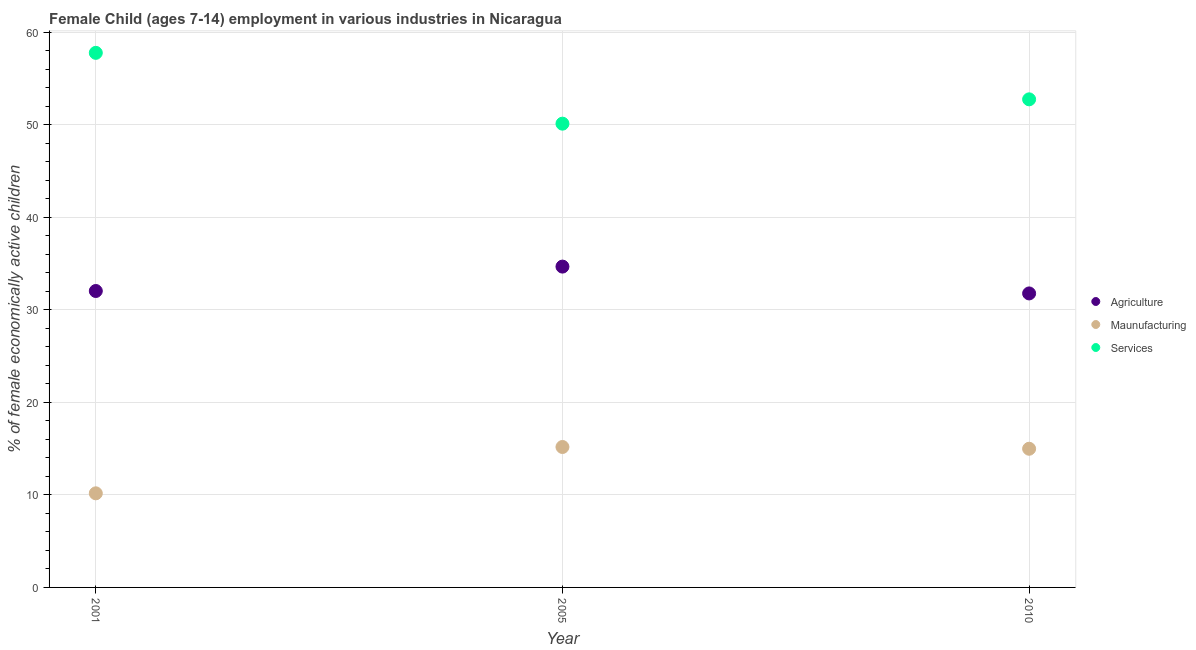How many different coloured dotlines are there?
Make the answer very short. 3. What is the percentage of economically active children in manufacturing in 2005?
Your answer should be compact. 15.18. Across all years, what is the maximum percentage of economically active children in agriculture?
Provide a succinct answer. 34.68. Across all years, what is the minimum percentage of economically active children in agriculture?
Ensure brevity in your answer.  31.78. In which year was the percentage of economically active children in manufacturing maximum?
Your answer should be compact. 2005. In which year was the percentage of economically active children in agriculture minimum?
Provide a short and direct response. 2010. What is the total percentage of economically active children in agriculture in the graph?
Make the answer very short. 98.5. What is the difference between the percentage of economically active children in agriculture in 2005 and that in 2010?
Provide a succinct answer. 2.9. What is the difference between the percentage of economically active children in services in 2001 and the percentage of economically active children in manufacturing in 2005?
Make the answer very short. 42.61. What is the average percentage of economically active children in services per year?
Provide a succinct answer. 53.56. In the year 2010, what is the difference between the percentage of economically active children in agriculture and percentage of economically active children in manufacturing?
Offer a terse response. 16.79. In how many years, is the percentage of economically active children in agriculture greater than 52 %?
Provide a succinct answer. 0. What is the ratio of the percentage of economically active children in agriculture in 2005 to that in 2010?
Your answer should be compact. 1.09. Is the percentage of economically active children in agriculture in 2001 less than that in 2005?
Your answer should be very brief. Yes. Is the difference between the percentage of economically active children in manufacturing in 2001 and 2010 greater than the difference between the percentage of economically active children in agriculture in 2001 and 2010?
Keep it short and to the point. No. What is the difference between the highest and the second highest percentage of economically active children in services?
Keep it short and to the point. 5.03. What is the difference between the highest and the lowest percentage of economically active children in manufacturing?
Offer a terse response. 5.01. In how many years, is the percentage of economically active children in services greater than the average percentage of economically active children in services taken over all years?
Provide a short and direct response. 1. Is the sum of the percentage of economically active children in manufacturing in 2001 and 2005 greater than the maximum percentage of economically active children in services across all years?
Offer a very short reply. No. Is it the case that in every year, the sum of the percentage of economically active children in agriculture and percentage of economically active children in manufacturing is greater than the percentage of economically active children in services?
Offer a very short reply. No. Does the percentage of economically active children in agriculture monotonically increase over the years?
Your response must be concise. No. Is the percentage of economically active children in services strictly greater than the percentage of economically active children in agriculture over the years?
Your response must be concise. Yes. Is the percentage of economically active children in manufacturing strictly less than the percentage of economically active children in agriculture over the years?
Offer a terse response. Yes. What is the difference between two consecutive major ticks on the Y-axis?
Provide a short and direct response. 10. Are the values on the major ticks of Y-axis written in scientific E-notation?
Your answer should be compact. No. Does the graph contain any zero values?
Your answer should be compact. No. Where does the legend appear in the graph?
Your answer should be very brief. Center right. How many legend labels are there?
Give a very brief answer. 3. What is the title of the graph?
Offer a very short reply. Female Child (ages 7-14) employment in various industries in Nicaragua. Does "Maunufacturing" appear as one of the legend labels in the graph?
Offer a terse response. Yes. What is the label or title of the X-axis?
Provide a succinct answer. Year. What is the label or title of the Y-axis?
Ensure brevity in your answer.  % of female economically active children. What is the % of female economically active children in Agriculture in 2001?
Ensure brevity in your answer.  32.04. What is the % of female economically active children of Maunufacturing in 2001?
Your answer should be very brief. 10.17. What is the % of female economically active children of Services in 2001?
Provide a short and direct response. 57.79. What is the % of female economically active children of Agriculture in 2005?
Provide a short and direct response. 34.68. What is the % of female economically active children of Maunufacturing in 2005?
Provide a short and direct response. 15.18. What is the % of female economically active children of Services in 2005?
Keep it short and to the point. 50.13. What is the % of female economically active children in Agriculture in 2010?
Your answer should be compact. 31.78. What is the % of female economically active children in Maunufacturing in 2010?
Offer a terse response. 14.99. What is the % of female economically active children in Services in 2010?
Give a very brief answer. 52.76. Across all years, what is the maximum % of female economically active children of Agriculture?
Offer a terse response. 34.68. Across all years, what is the maximum % of female economically active children in Maunufacturing?
Provide a short and direct response. 15.18. Across all years, what is the maximum % of female economically active children of Services?
Provide a succinct answer. 57.79. Across all years, what is the minimum % of female economically active children in Agriculture?
Offer a terse response. 31.78. Across all years, what is the minimum % of female economically active children in Maunufacturing?
Your answer should be very brief. 10.17. Across all years, what is the minimum % of female economically active children in Services?
Your answer should be very brief. 50.13. What is the total % of female economically active children in Agriculture in the graph?
Keep it short and to the point. 98.5. What is the total % of female economically active children in Maunufacturing in the graph?
Provide a succinct answer. 40.34. What is the total % of female economically active children in Services in the graph?
Offer a very short reply. 160.68. What is the difference between the % of female economically active children in Agriculture in 2001 and that in 2005?
Your response must be concise. -2.64. What is the difference between the % of female economically active children of Maunufacturing in 2001 and that in 2005?
Make the answer very short. -5.01. What is the difference between the % of female economically active children of Services in 2001 and that in 2005?
Your answer should be compact. 7.66. What is the difference between the % of female economically active children of Agriculture in 2001 and that in 2010?
Provide a short and direct response. 0.26. What is the difference between the % of female economically active children in Maunufacturing in 2001 and that in 2010?
Make the answer very short. -4.82. What is the difference between the % of female economically active children in Services in 2001 and that in 2010?
Your answer should be very brief. 5.03. What is the difference between the % of female economically active children of Agriculture in 2005 and that in 2010?
Your response must be concise. 2.9. What is the difference between the % of female economically active children in Maunufacturing in 2005 and that in 2010?
Offer a terse response. 0.19. What is the difference between the % of female economically active children of Services in 2005 and that in 2010?
Your answer should be compact. -2.63. What is the difference between the % of female economically active children of Agriculture in 2001 and the % of female economically active children of Maunufacturing in 2005?
Your answer should be compact. 16.86. What is the difference between the % of female economically active children of Agriculture in 2001 and the % of female economically active children of Services in 2005?
Provide a succinct answer. -18.09. What is the difference between the % of female economically active children of Maunufacturing in 2001 and the % of female economically active children of Services in 2005?
Provide a short and direct response. -39.96. What is the difference between the % of female economically active children in Agriculture in 2001 and the % of female economically active children in Maunufacturing in 2010?
Your answer should be very brief. 17.05. What is the difference between the % of female economically active children in Agriculture in 2001 and the % of female economically active children in Services in 2010?
Give a very brief answer. -20.72. What is the difference between the % of female economically active children of Maunufacturing in 2001 and the % of female economically active children of Services in 2010?
Your response must be concise. -42.59. What is the difference between the % of female economically active children of Agriculture in 2005 and the % of female economically active children of Maunufacturing in 2010?
Your response must be concise. 19.69. What is the difference between the % of female economically active children of Agriculture in 2005 and the % of female economically active children of Services in 2010?
Offer a very short reply. -18.08. What is the difference between the % of female economically active children in Maunufacturing in 2005 and the % of female economically active children in Services in 2010?
Ensure brevity in your answer.  -37.58. What is the average % of female economically active children in Agriculture per year?
Offer a terse response. 32.83. What is the average % of female economically active children of Maunufacturing per year?
Your answer should be compact. 13.45. What is the average % of female economically active children in Services per year?
Offer a terse response. 53.56. In the year 2001, what is the difference between the % of female economically active children of Agriculture and % of female economically active children of Maunufacturing?
Offer a very short reply. 21.87. In the year 2001, what is the difference between the % of female economically active children in Agriculture and % of female economically active children in Services?
Provide a short and direct response. -25.74. In the year 2001, what is the difference between the % of female economically active children in Maunufacturing and % of female economically active children in Services?
Offer a very short reply. -47.61. In the year 2005, what is the difference between the % of female economically active children in Agriculture and % of female economically active children in Maunufacturing?
Offer a terse response. 19.5. In the year 2005, what is the difference between the % of female economically active children of Agriculture and % of female economically active children of Services?
Give a very brief answer. -15.45. In the year 2005, what is the difference between the % of female economically active children of Maunufacturing and % of female economically active children of Services?
Offer a very short reply. -34.95. In the year 2010, what is the difference between the % of female economically active children in Agriculture and % of female economically active children in Maunufacturing?
Ensure brevity in your answer.  16.79. In the year 2010, what is the difference between the % of female economically active children of Agriculture and % of female economically active children of Services?
Your response must be concise. -20.98. In the year 2010, what is the difference between the % of female economically active children in Maunufacturing and % of female economically active children in Services?
Your answer should be compact. -37.77. What is the ratio of the % of female economically active children of Agriculture in 2001 to that in 2005?
Offer a very short reply. 0.92. What is the ratio of the % of female economically active children in Maunufacturing in 2001 to that in 2005?
Your answer should be compact. 0.67. What is the ratio of the % of female economically active children in Services in 2001 to that in 2005?
Offer a very short reply. 1.15. What is the ratio of the % of female economically active children in Agriculture in 2001 to that in 2010?
Provide a short and direct response. 1.01. What is the ratio of the % of female economically active children of Maunufacturing in 2001 to that in 2010?
Provide a short and direct response. 0.68. What is the ratio of the % of female economically active children in Services in 2001 to that in 2010?
Offer a very short reply. 1.1. What is the ratio of the % of female economically active children in Agriculture in 2005 to that in 2010?
Ensure brevity in your answer.  1.09. What is the ratio of the % of female economically active children in Maunufacturing in 2005 to that in 2010?
Provide a short and direct response. 1.01. What is the ratio of the % of female economically active children in Services in 2005 to that in 2010?
Your answer should be very brief. 0.95. What is the difference between the highest and the second highest % of female economically active children of Agriculture?
Your answer should be very brief. 2.64. What is the difference between the highest and the second highest % of female economically active children of Maunufacturing?
Offer a very short reply. 0.19. What is the difference between the highest and the second highest % of female economically active children in Services?
Give a very brief answer. 5.03. What is the difference between the highest and the lowest % of female economically active children in Agriculture?
Your response must be concise. 2.9. What is the difference between the highest and the lowest % of female economically active children in Maunufacturing?
Your answer should be very brief. 5.01. What is the difference between the highest and the lowest % of female economically active children of Services?
Your answer should be compact. 7.66. 